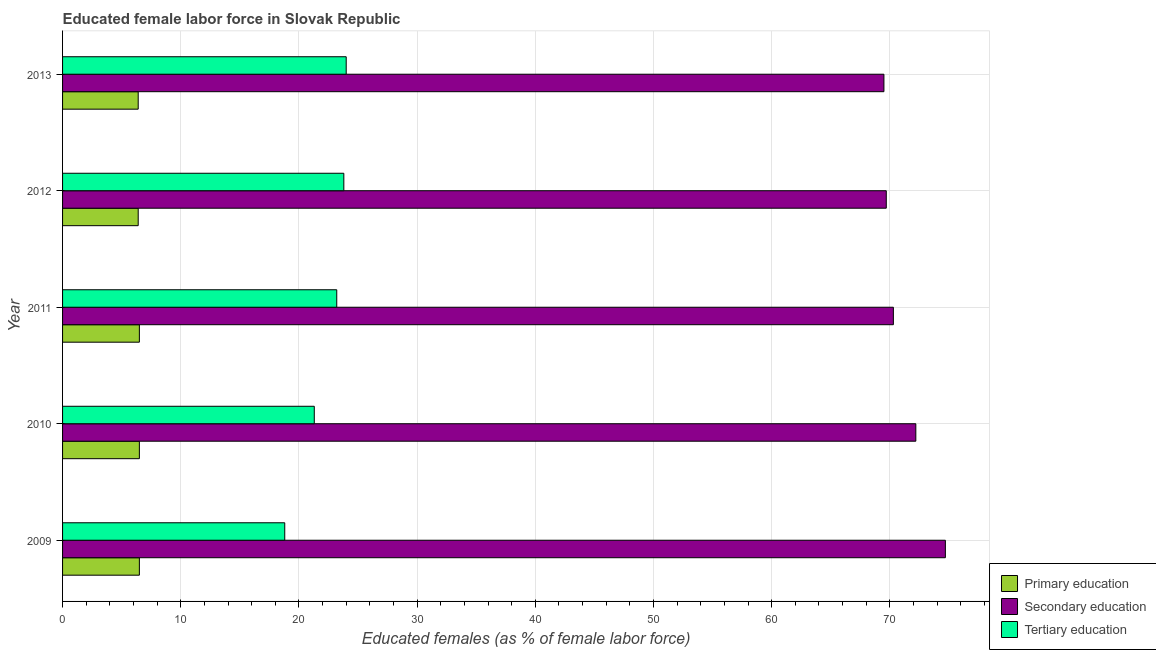Are the number of bars per tick equal to the number of legend labels?
Offer a terse response. Yes. Are the number of bars on each tick of the Y-axis equal?
Provide a short and direct response. Yes. How many bars are there on the 2nd tick from the top?
Offer a terse response. 3. What is the label of the 5th group of bars from the top?
Provide a short and direct response. 2009. What is the percentage of female labor force who received secondary education in 2010?
Ensure brevity in your answer.  72.2. Across all years, what is the maximum percentage of female labor force who received tertiary education?
Give a very brief answer. 24. Across all years, what is the minimum percentage of female labor force who received primary education?
Offer a terse response. 6.4. In which year was the percentage of female labor force who received secondary education maximum?
Your answer should be compact. 2009. In which year was the percentage of female labor force who received tertiary education minimum?
Keep it short and to the point. 2009. What is the total percentage of female labor force who received secondary education in the graph?
Provide a short and direct response. 356.4. What is the difference between the percentage of female labor force who received tertiary education in 2011 and the percentage of female labor force who received primary education in 2012?
Your answer should be very brief. 16.8. What is the average percentage of female labor force who received tertiary education per year?
Give a very brief answer. 22.22. In the year 2010, what is the difference between the percentage of female labor force who received primary education and percentage of female labor force who received tertiary education?
Your response must be concise. -14.8. In how many years, is the percentage of female labor force who received primary education greater than 64 %?
Your answer should be very brief. 0. Is the percentage of female labor force who received primary education in 2009 less than that in 2011?
Give a very brief answer. No. What is the difference between the highest and the second highest percentage of female labor force who received tertiary education?
Give a very brief answer. 0.2. What is the difference between the highest and the lowest percentage of female labor force who received secondary education?
Keep it short and to the point. 5.2. In how many years, is the percentage of female labor force who received primary education greater than the average percentage of female labor force who received primary education taken over all years?
Your answer should be compact. 3. What does the 1st bar from the top in 2009 represents?
Offer a terse response. Tertiary education. What does the 1st bar from the bottom in 2010 represents?
Offer a very short reply. Primary education. Is it the case that in every year, the sum of the percentage of female labor force who received primary education and percentage of female labor force who received secondary education is greater than the percentage of female labor force who received tertiary education?
Provide a succinct answer. Yes. How many bars are there?
Make the answer very short. 15. How many years are there in the graph?
Offer a very short reply. 5. Does the graph contain grids?
Provide a short and direct response. Yes. Where does the legend appear in the graph?
Your answer should be very brief. Bottom right. How many legend labels are there?
Your answer should be compact. 3. How are the legend labels stacked?
Ensure brevity in your answer.  Vertical. What is the title of the graph?
Your answer should be very brief. Educated female labor force in Slovak Republic. What is the label or title of the X-axis?
Provide a short and direct response. Educated females (as % of female labor force). What is the Educated females (as % of female labor force) of Primary education in 2009?
Ensure brevity in your answer.  6.5. What is the Educated females (as % of female labor force) of Secondary education in 2009?
Your answer should be very brief. 74.7. What is the Educated females (as % of female labor force) of Tertiary education in 2009?
Keep it short and to the point. 18.8. What is the Educated females (as % of female labor force) in Secondary education in 2010?
Your response must be concise. 72.2. What is the Educated females (as % of female labor force) of Tertiary education in 2010?
Provide a succinct answer. 21.3. What is the Educated females (as % of female labor force) in Secondary education in 2011?
Provide a short and direct response. 70.3. What is the Educated females (as % of female labor force) of Tertiary education in 2011?
Provide a succinct answer. 23.2. What is the Educated females (as % of female labor force) in Primary education in 2012?
Your answer should be very brief. 6.4. What is the Educated females (as % of female labor force) in Secondary education in 2012?
Your answer should be very brief. 69.7. What is the Educated females (as % of female labor force) in Tertiary education in 2012?
Offer a terse response. 23.8. What is the Educated females (as % of female labor force) in Primary education in 2013?
Provide a short and direct response. 6.4. What is the Educated females (as % of female labor force) of Secondary education in 2013?
Your answer should be compact. 69.5. Across all years, what is the maximum Educated females (as % of female labor force) of Secondary education?
Offer a very short reply. 74.7. Across all years, what is the maximum Educated females (as % of female labor force) in Tertiary education?
Offer a terse response. 24. Across all years, what is the minimum Educated females (as % of female labor force) in Primary education?
Keep it short and to the point. 6.4. Across all years, what is the minimum Educated females (as % of female labor force) in Secondary education?
Your answer should be very brief. 69.5. Across all years, what is the minimum Educated females (as % of female labor force) in Tertiary education?
Offer a terse response. 18.8. What is the total Educated females (as % of female labor force) in Primary education in the graph?
Keep it short and to the point. 32.3. What is the total Educated females (as % of female labor force) of Secondary education in the graph?
Give a very brief answer. 356.4. What is the total Educated females (as % of female labor force) in Tertiary education in the graph?
Ensure brevity in your answer.  111.1. What is the difference between the Educated females (as % of female labor force) in Tertiary education in 2009 and that in 2010?
Give a very brief answer. -2.5. What is the difference between the Educated females (as % of female labor force) in Primary education in 2009 and that in 2011?
Give a very brief answer. 0. What is the difference between the Educated females (as % of female labor force) in Secondary education in 2009 and that in 2011?
Provide a short and direct response. 4.4. What is the difference between the Educated females (as % of female labor force) of Tertiary education in 2009 and that in 2011?
Your answer should be very brief. -4.4. What is the difference between the Educated females (as % of female labor force) of Tertiary education in 2009 and that in 2012?
Provide a short and direct response. -5. What is the difference between the Educated females (as % of female labor force) in Primary education in 2009 and that in 2013?
Offer a very short reply. 0.1. What is the difference between the Educated females (as % of female labor force) of Tertiary education in 2009 and that in 2013?
Make the answer very short. -5.2. What is the difference between the Educated females (as % of female labor force) in Tertiary education in 2010 and that in 2011?
Offer a terse response. -1.9. What is the difference between the Educated females (as % of female labor force) in Primary education in 2010 and that in 2012?
Make the answer very short. 0.1. What is the difference between the Educated females (as % of female labor force) in Secondary education in 2010 and that in 2012?
Your answer should be compact. 2.5. What is the difference between the Educated females (as % of female labor force) of Primary education in 2010 and that in 2013?
Ensure brevity in your answer.  0.1. What is the difference between the Educated females (as % of female labor force) in Primary education in 2011 and that in 2012?
Provide a succinct answer. 0.1. What is the difference between the Educated females (as % of female labor force) of Secondary education in 2011 and that in 2012?
Your answer should be compact. 0.6. What is the difference between the Educated females (as % of female labor force) of Tertiary education in 2011 and that in 2012?
Give a very brief answer. -0.6. What is the difference between the Educated females (as % of female labor force) of Primary education in 2011 and that in 2013?
Make the answer very short. 0.1. What is the difference between the Educated females (as % of female labor force) in Secondary education in 2011 and that in 2013?
Ensure brevity in your answer.  0.8. What is the difference between the Educated females (as % of female labor force) in Primary education in 2012 and that in 2013?
Keep it short and to the point. 0. What is the difference between the Educated females (as % of female labor force) in Primary education in 2009 and the Educated females (as % of female labor force) in Secondary education in 2010?
Offer a very short reply. -65.7. What is the difference between the Educated females (as % of female labor force) in Primary education in 2009 and the Educated females (as % of female labor force) in Tertiary education in 2010?
Provide a succinct answer. -14.8. What is the difference between the Educated females (as % of female labor force) of Secondary education in 2009 and the Educated females (as % of female labor force) of Tertiary education in 2010?
Provide a succinct answer. 53.4. What is the difference between the Educated females (as % of female labor force) in Primary education in 2009 and the Educated females (as % of female labor force) in Secondary education in 2011?
Your response must be concise. -63.8. What is the difference between the Educated females (as % of female labor force) in Primary education in 2009 and the Educated females (as % of female labor force) in Tertiary education in 2011?
Offer a terse response. -16.7. What is the difference between the Educated females (as % of female labor force) in Secondary education in 2009 and the Educated females (as % of female labor force) in Tertiary education in 2011?
Offer a very short reply. 51.5. What is the difference between the Educated females (as % of female labor force) of Primary education in 2009 and the Educated females (as % of female labor force) of Secondary education in 2012?
Provide a succinct answer. -63.2. What is the difference between the Educated females (as % of female labor force) in Primary education in 2009 and the Educated females (as % of female labor force) in Tertiary education in 2012?
Ensure brevity in your answer.  -17.3. What is the difference between the Educated females (as % of female labor force) in Secondary education in 2009 and the Educated females (as % of female labor force) in Tertiary education in 2012?
Your answer should be very brief. 50.9. What is the difference between the Educated females (as % of female labor force) in Primary education in 2009 and the Educated females (as % of female labor force) in Secondary education in 2013?
Offer a terse response. -63. What is the difference between the Educated females (as % of female labor force) in Primary education in 2009 and the Educated females (as % of female labor force) in Tertiary education in 2013?
Your answer should be very brief. -17.5. What is the difference between the Educated females (as % of female labor force) in Secondary education in 2009 and the Educated females (as % of female labor force) in Tertiary education in 2013?
Offer a very short reply. 50.7. What is the difference between the Educated females (as % of female labor force) in Primary education in 2010 and the Educated females (as % of female labor force) in Secondary education in 2011?
Ensure brevity in your answer.  -63.8. What is the difference between the Educated females (as % of female labor force) of Primary education in 2010 and the Educated females (as % of female labor force) of Tertiary education in 2011?
Your response must be concise. -16.7. What is the difference between the Educated females (as % of female labor force) in Primary education in 2010 and the Educated females (as % of female labor force) in Secondary education in 2012?
Make the answer very short. -63.2. What is the difference between the Educated females (as % of female labor force) in Primary education in 2010 and the Educated females (as % of female labor force) in Tertiary education in 2012?
Your answer should be very brief. -17.3. What is the difference between the Educated females (as % of female labor force) of Secondary education in 2010 and the Educated females (as % of female labor force) of Tertiary education in 2012?
Your response must be concise. 48.4. What is the difference between the Educated females (as % of female labor force) of Primary education in 2010 and the Educated females (as % of female labor force) of Secondary education in 2013?
Keep it short and to the point. -63. What is the difference between the Educated females (as % of female labor force) of Primary education in 2010 and the Educated females (as % of female labor force) of Tertiary education in 2013?
Keep it short and to the point. -17.5. What is the difference between the Educated females (as % of female labor force) in Secondary education in 2010 and the Educated females (as % of female labor force) in Tertiary education in 2013?
Your answer should be compact. 48.2. What is the difference between the Educated females (as % of female labor force) in Primary education in 2011 and the Educated females (as % of female labor force) in Secondary education in 2012?
Ensure brevity in your answer.  -63.2. What is the difference between the Educated females (as % of female labor force) of Primary education in 2011 and the Educated females (as % of female labor force) of Tertiary education in 2012?
Offer a terse response. -17.3. What is the difference between the Educated females (as % of female labor force) in Secondary education in 2011 and the Educated females (as % of female labor force) in Tertiary education in 2012?
Offer a very short reply. 46.5. What is the difference between the Educated females (as % of female labor force) of Primary education in 2011 and the Educated females (as % of female labor force) of Secondary education in 2013?
Offer a very short reply. -63. What is the difference between the Educated females (as % of female labor force) in Primary education in 2011 and the Educated females (as % of female labor force) in Tertiary education in 2013?
Your response must be concise. -17.5. What is the difference between the Educated females (as % of female labor force) of Secondary education in 2011 and the Educated females (as % of female labor force) of Tertiary education in 2013?
Provide a short and direct response. 46.3. What is the difference between the Educated females (as % of female labor force) in Primary education in 2012 and the Educated females (as % of female labor force) in Secondary education in 2013?
Your response must be concise. -63.1. What is the difference between the Educated females (as % of female labor force) of Primary education in 2012 and the Educated females (as % of female labor force) of Tertiary education in 2013?
Your answer should be compact. -17.6. What is the difference between the Educated females (as % of female labor force) in Secondary education in 2012 and the Educated females (as % of female labor force) in Tertiary education in 2013?
Keep it short and to the point. 45.7. What is the average Educated females (as % of female labor force) in Primary education per year?
Your answer should be compact. 6.46. What is the average Educated females (as % of female labor force) in Secondary education per year?
Give a very brief answer. 71.28. What is the average Educated females (as % of female labor force) of Tertiary education per year?
Give a very brief answer. 22.22. In the year 2009, what is the difference between the Educated females (as % of female labor force) of Primary education and Educated females (as % of female labor force) of Secondary education?
Your response must be concise. -68.2. In the year 2009, what is the difference between the Educated females (as % of female labor force) in Primary education and Educated females (as % of female labor force) in Tertiary education?
Give a very brief answer. -12.3. In the year 2009, what is the difference between the Educated females (as % of female labor force) in Secondary education and Educated females (as % of female labor force) in Tertiary education?
Give a very brief answer. 55.9. In the year 2010, what is the difference between the Educated females (as % of female labor force) of Primary education and Educated females (as % of female labor force) of Secondary education?
Offer a terse response. -65.7. In the year 2010, what is the difference between the Educated females (as % of female labor force) of Primary education and Educated females (as % of female labor force) of Tertiary education?
Make the answer very short. -14.8. In the year 2010, what is the difference between the Educated females (as % of female labor force) of Secondary education and Educated females (as % of female labor force) of Tertiary education?
Your response must be concise. 50.9. In the year 2011, what is the difference between the Educated females (as % of female labor force) of Primary education and Educated females (as % of female labor force) of Secondary education?
Offer a terse response. -63.8. In the year 2011, what is the difference between the Educated females (as % of female labor force) of Primary education and Educated females (as % of female labor force) of Tertiary education?
Provide a succinct answer. -16.7. In the year 2011, what is the difference between the Educated females (as % of female labor force) in Secondary education and Educated females (as % of female labor force) in Tertiary education?
Ensure brevity in your answer.  47.1. In the year 2012, what is the difference between the Educated females (as % of female labor force) in Primary education and Educated females (as % of female labor force) in Secondary education?
Provide a short and direct response. -63.3. In the year 2012, what is the difference between the Educated females (as % of female labor force) of Primary education and Educated females (as % of female labor force) of Tertiary education?
Provide a short and direct response. -17.4. In the year 2012, what is the difference between the Educated females (as % of female labor force) in Secondary education and Educated females (as % of female labor force) in Tertiary education?
Your answer should be compact. 45.9. In the year 2013, what is the difference between the Educated females (as % of female labor force) of Primary education and Educated females (as % of female labor force) of Secondary education?
Your response must be concise. -63.1. In the year 2013, what is the difference between the Educated females (as % of female labor force) in Primary education and Educated females (as % of female labor force) in Tertiary education?
Offer a terse response. -17.6. In the year 2013, what is the difference between the Educated females (as % of female labor force) of Secondary education and Educated females (as % of female labor force) of Tertiary education?
Offer a terse response. 45.5. What is the ratio of the Educated females (as % of female labor force) of Secondary education in 2009 to that in 2010?
Your response must be concise. 1.03. What is the ratio of the Educated females (as % of female labor force) of Tertiary education in 2009 to that in 2010?
Make the answer very short. 0.88. What is the ratio of the Educated females (as % of female labor force) in Secondary education in 2009 to that in 2011?
Give a very brief answer. 1.06. What is the ratio of the Educated females (as % of female labor force) in Tertiary education in 2009 to that in 2011?
Your response must be concise. 0.81. What is the ratio of the Educated females (as % of female labor force) in Primary education in 2009 to that in 2012?
Provide a short and direct response. 1.02. What is the ratio of the Educated females (as % of female labor force) of Secondary education in 2009 to that in 2012?
Give a very brief answer. 1.07. What is the ratio of the Educated females (as % of female labor force) of Tertiary education in 2009 to that in 2012?
Provide a short and direct response. 0.79. What is the ratio of the Educated females (as % of female labor force) in Primary education in 2009 to that in 2013?
Your answer should be compact. 1.02. What is the ratio of the Educated females (as % of female labor force) in Secondary education in 2009 to that in 2013?
Give a very brief answer. 1.07. What is the ratio of the Educated females (as % of female labor force) in Tertiary education in 2009 to that in 2013?
Offer a terse response. 0.78. What is the ratio of the Educated females (as % of female labor force) of Primary education in 2010 to that in 2011?
Your answer should be very brief. 1. What is the ratio of the Educated females (as % of female labor force) of Tertiary education in 2010 to that in 2011?
Your response must be concise. 0.92. What is the ratio of the Educated females (as % of female labor force) in Primary education in 2010 to that in 2012?
Make the answer very short. 1.02. What is the ratio of the Educated females (as % of female labor force) in Secondary education in 2010 to that in 2012?
Your answer should be compact. 1.04. What is the ratio of the Educated females (as % of female labor force) of Tertiary education in 2010 to that in 2012?
Keep it short and to the point. 0.9. What is the ratio of the Educated females (as % of female labor force) of Primary education in 2010 to that in 2013?
Your response must be concise. 1.02. What is the ratio of the Educated females (as % of female labor force) in Secondary education in 2010 to that in 2013?
Make the answer very short. 1.04. What is the ratio of the Educated females (as % of female labor force) of Tertiary education in 2010 to that in 2013?
Provide a succinct answer. 0.89. What is the ratio of the Educated females (as % of female labor force) in Primary education in 2011 to that in 2012?
Provide a short and direct response. 1.02. What is the ratio of the Educated females (as % of female labor force) of Secondary education in 2011 to that in 2012?
Provide a succinct answer. 1.01. What is the ratio of the Educated females (as % of female labor force) in Tertiary education in 2011 to that in 2012?
Your answer should be compact. 0.97. What is the ratio of the Educated females (as % of female labor force) of Primary education in 2011 to that in 2013?
Offer a terse response. 1.02. What is the ratio of the Educated females (as % of female labor force) of Secondary education in 2011 to that in 2013?
Make the answer very short. 1.01. What is the ratio of the Educated females (as % of female labor force) in Tertiary education in 2011 to that in 2013?
Keep it short and to the point. 0.97. What is the ratio of the Educated females (as % of female labor force) of Primary education in 2012 to that in 2013?
Make the answer very short. 1. What is the difference between the highest and the second highest Educated females (as % of female labor force) in Primary education?
Keep it short and to the point. 0. What is the difference between the highest and the lowest Educated females (as % of female labor force) of Primary education?
Give a very brief answer. 0.1. What is the difference between the highest and the lowest Educated females (as % of female labor force) in Secondary education?
Ensure brevity in your answer.  5.2. What is the difference between the highest and the lowest Educated females (as % of female labor force) in Tertiary education?
Offer a terse response. 5.2. 